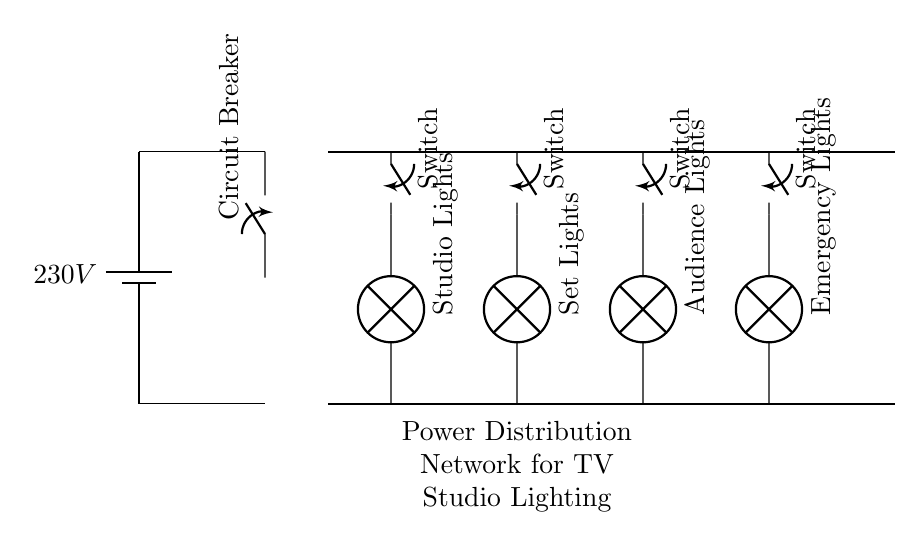What is the main voltage supply of the circuit? The circuit is powered by a battery, which provides a voltage of 230 volts as indicated in the diagram.
Answer: 230V How many switches are present in the lighting circuit? There are four switches in total, one for each lighting circuit (Studio Lights, Set Lights, Audience Lights, Emergency Lights) as shown in the diagram.
Answer: 4 What type of circuit protection is used in this diagram? A circuit breaker is depicted at the beginning of the circuit, which is utilized to protect the circuit from overloads and short circuits.
Answer: Circuit Breaker Which lights are connected to the switch in the first position? The switch in the first position is connected to the Studio Lights, as indicated by the line connecting the switch to the lamp labeled "Studio Lights."
Answer: Studio Lights If all lights are switched on, how many lighting circuits are active? Since there are four distinct lighting circuits, if all are switched on, all four circuits will be active at the same time.
Answer: 4 What is the purpose of the distribution bus in the circuit? The distribution bus serves as the main pathway that distributes the power received from the main supply to the various lighting circuits connected to it.
Answer: Distribution of power What would happen if the circuit breaker is activated? If the circuit breaker activates, it interrupts the circuit, stopping the flow of electricity to all connected loads, which ensures safety by preventing potential damage from overloads.
Answer: Interrupt the circuit 